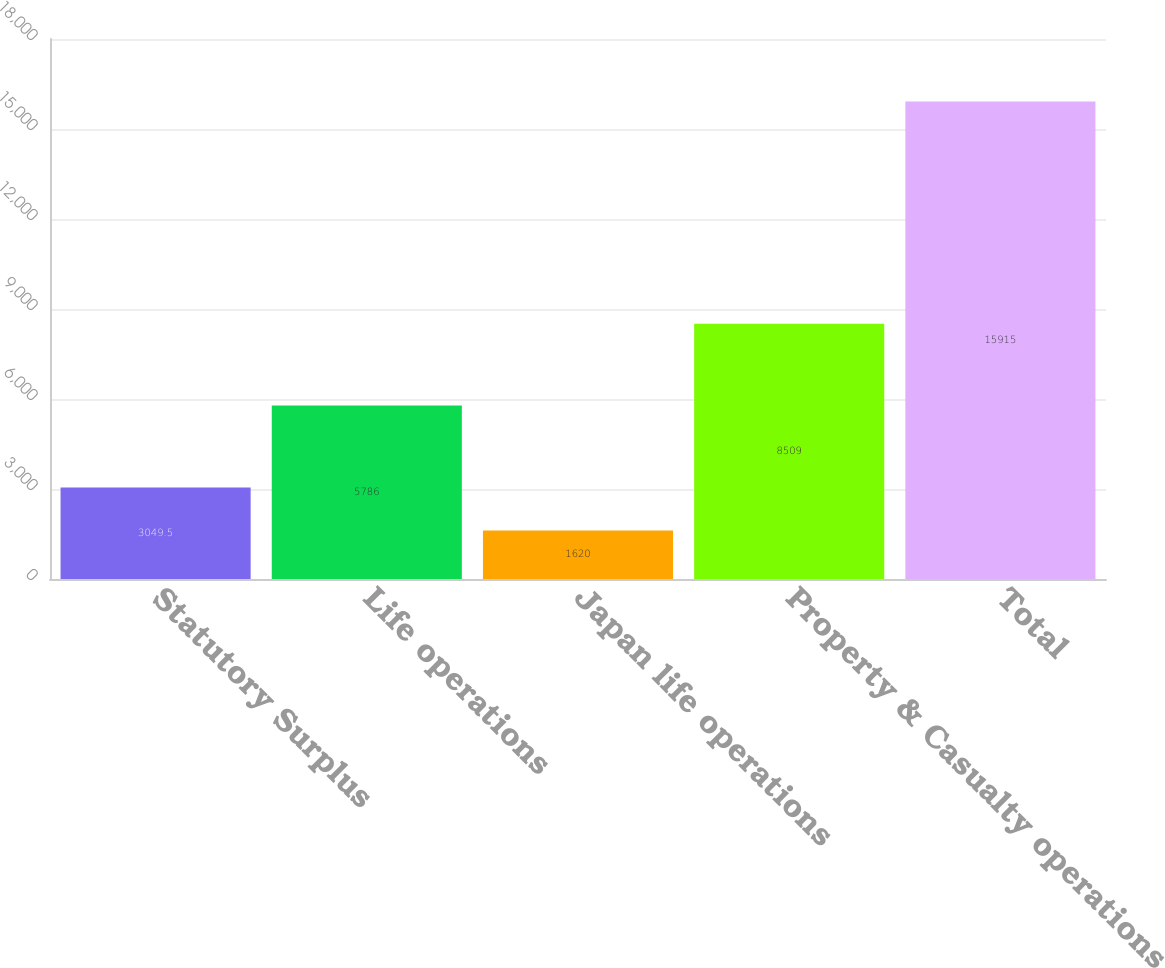Convert chart. <chart><loc_0><loc_0><loc_500><loc_500><bar_chart><fcel>Statutory Surplus<fcel>Life operations<fcel>Japan life operations<fcel>Property & Casualty operations<fcel>Total<nl><fcel>3049.5<fcel>5786<fcel>1620<fcel>8509<fcel>15915<nl></chart> 